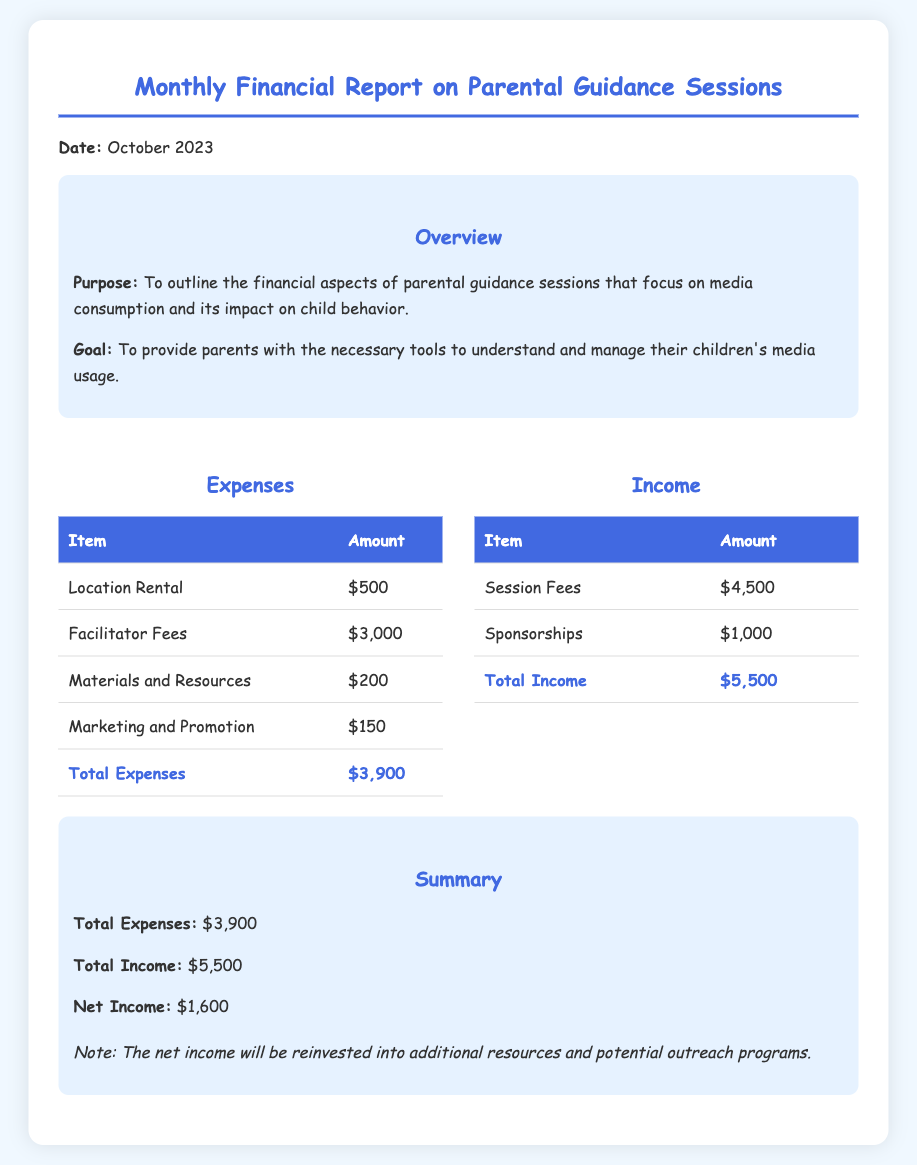What is the total amount of expenses? The total expenses are listed in the document under the Expenses section and add up to $3,900.
Answer: $3,900 What is the total income from session fees? The session fees are specifically mentioned in the Income section, which states they amount to $4,500.
Answer: $4,500 What is the net income for the month? The net income is calculated as total income minus total expenses, resulting in $5,500 - $3,900 = $1,600.
Answer: $1,600 What was spent on marketing and promotion? The document lists marketing and promotion costs as one of the expense items and specifies the amount as $150.
Answer: $150 What is the purpose of the parental guidance sessions? The purpose outlined in the overview section is to outline the financial aspects of the sessions that help parents understand media effects on child behavior.
Answer: To outline the financial aspects of parental guidance sessions What are the facilitator fees? The document details facilitator fees in the Expenses section, stating the amount is $3,000.
Answer: $3,000 How much was generated from sponsorships? The sponsorship amount is explicitly mentioned in the Income section and is $1,000.
Answer: $1,000 What is the total amount designated for materials and resources? The materials and resources expense is listed in the document with an amount of $200.
Answer: $200 What type of document is this? The document is a financial report focused on parental guidance sessions regarding media consumption.
Answer: Monthly Financial Report 